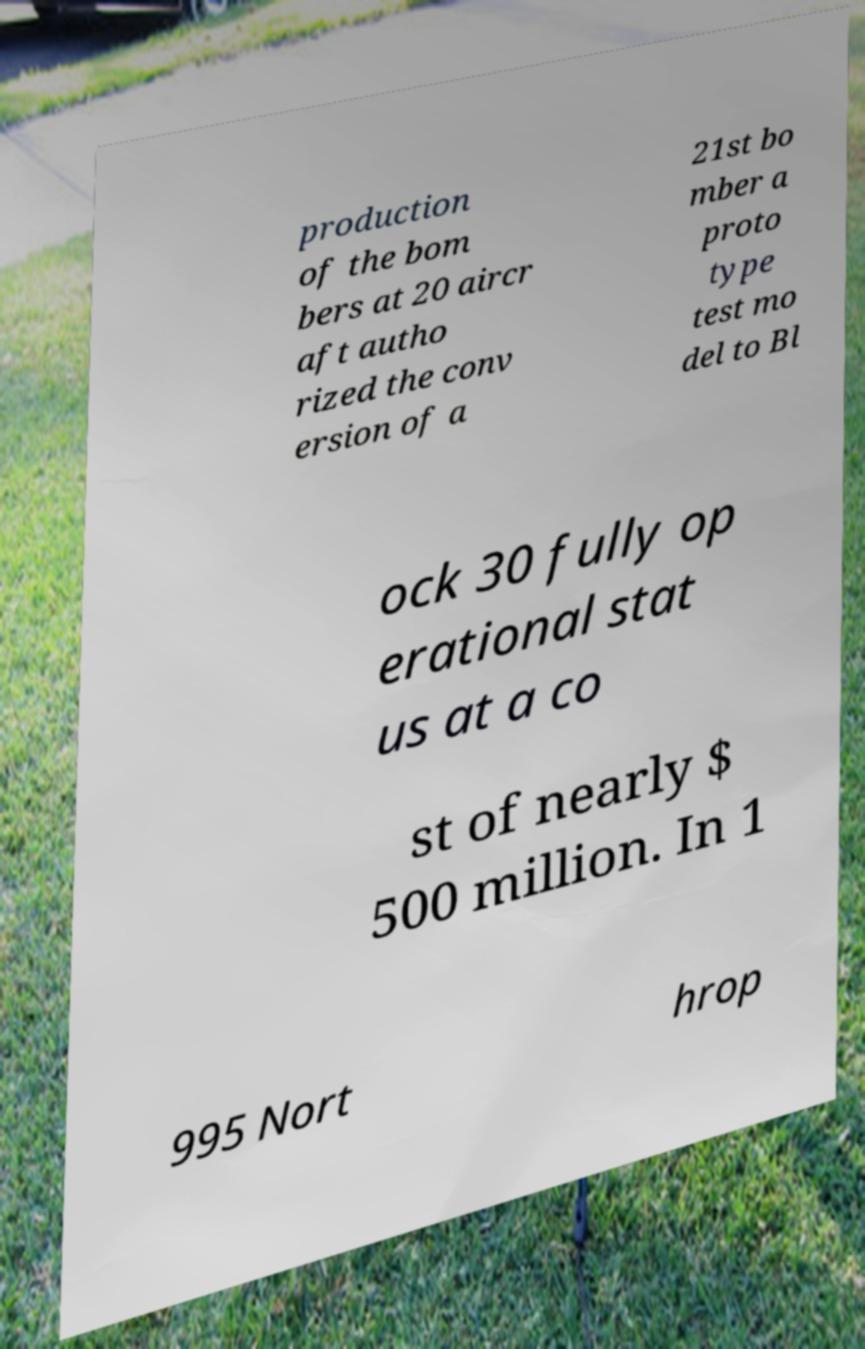Please identify and transcribe the text found in this image. production of the bom bers at 20 aircr aft autho rized the conv ersion of a 21st bo mber a proto type test mo del to Bl ock 30 fully op erational stat us at a co st of nearly $ 500 million. In 1 995 Nort hrop 